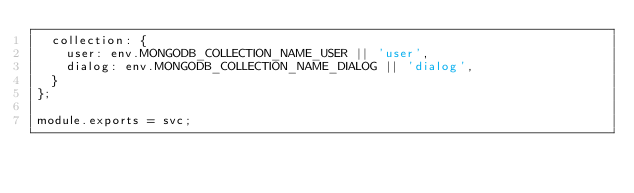<code> <loc_0><loc_0><loc_500><loc_500><_JavaScript_>  collection: {
    user: env.MONGODB_COLLECTION_NAME_USER || 'user',
    dialog: env.MONGODB_COLLECTION_NAME_DIALOG || 'dialog',
  }
};

module.exports = svc;
</code> 